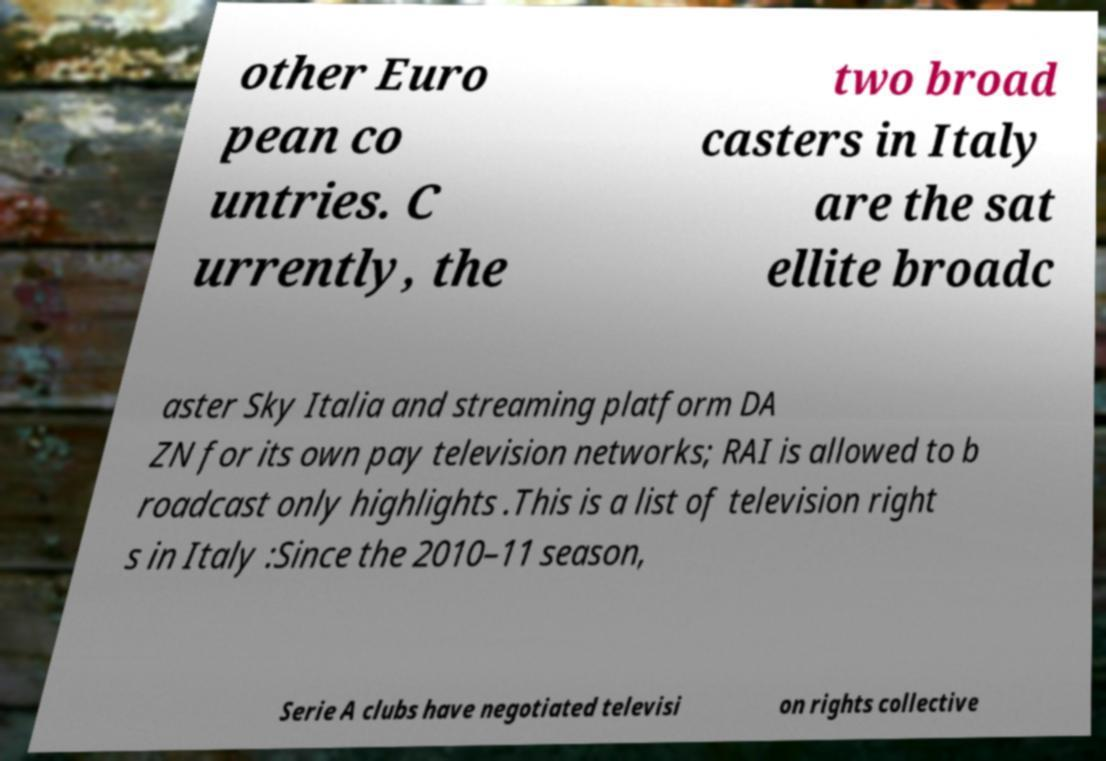Please read and relay the text visible in this image. What does it say? other Euro pean co untries. C urrently, the two broad casters in Italy are the sat ellite broadc aster Sky Italia and streaming platform DA ZN for its own pay television networks; RAI is allowed to b roadcast only highlights .This is a list of television right s in Italy :Since the 2010–11 season, Serie A clubs have negotiated televisi on rights collective 